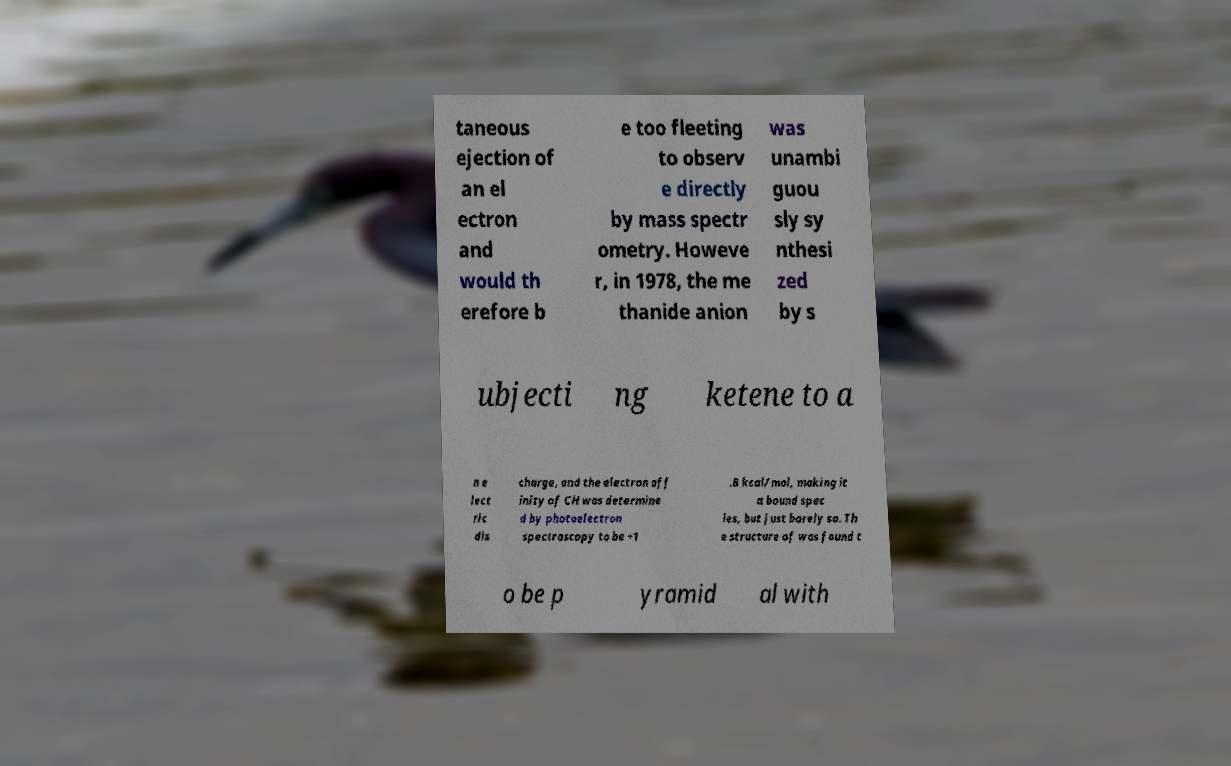For documentation purposes, I need the text within this image transcribed. Could you provide that? taneous ejection of an el ectron and would th erefore b e too fleeting to observ e directly by mass spectr ometry. Howeve r, in 1978, the me thanide anion was unambi guou sly sy nthesi zed by s ubjecti ng ketene to a n e lect ric dis charge, and the electron aff inity of CH was determine d by photoelectron spectroscopy to be +1 .8 kcal/mol, making it a bound spec ies, but just barely so. Th e structure of was found t o be p yramid al with 